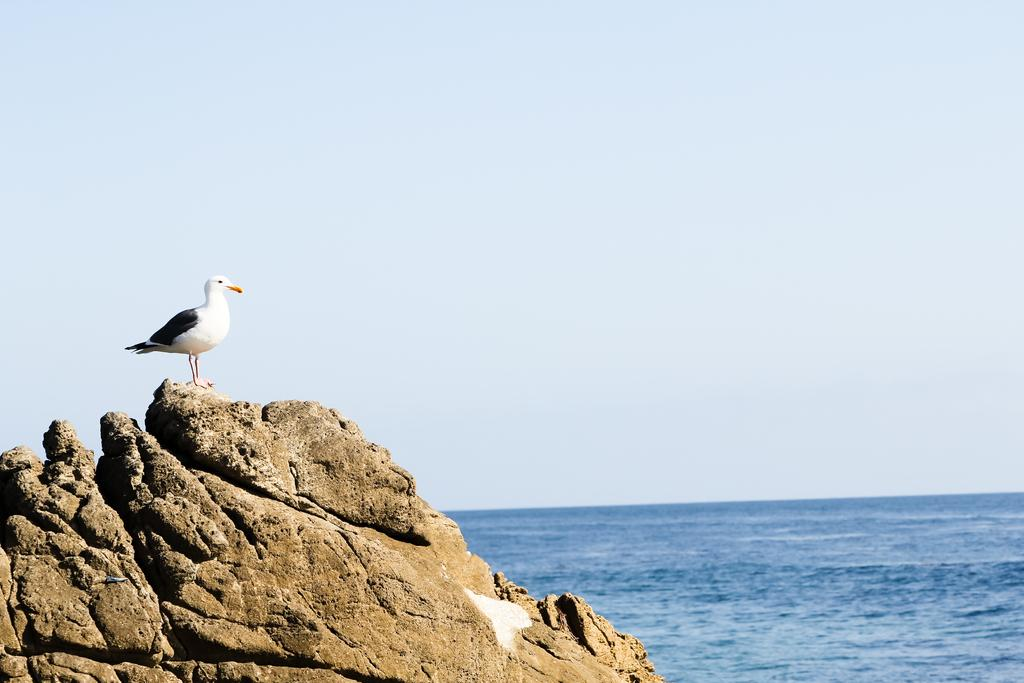What type of animal is in the image? There is a bird in the image. What is the bird standing on? The bird is standing on rocks. What type of water can be seen in the image? There is water visible in the image, and it is in an ocean. What is visible in the background of the image? The sky is visible in the background of the image. Can you see any ghosts or icicles in the image? No, there are no ghosts or icicles present in the image. 